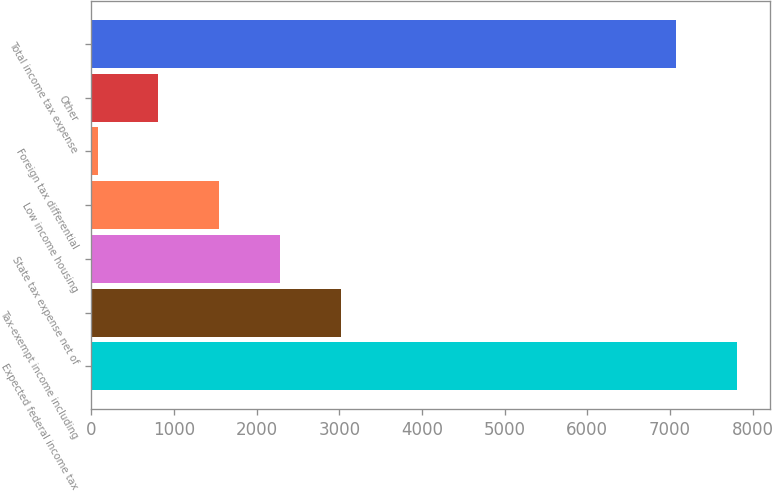<chart> <loc_0><loc_0><loc_500><loc_500><bar_chart><fcel>Expected federal income tax<fcel>Tax-exempt income including<fcel>State tax expense net of<fcel>Low income housing<fcel>Foreign tax differential<fcel>Other<fcel>Total income tax expense<nl><fcel>7812.9<fcel>3017.6<fcel>2282.7<fcel>1547.8<fcel>78<fcel>812.9<fcel>7078<nl></chart> 